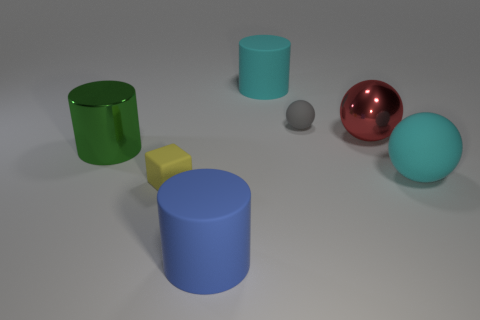Can you tell me what objects are in the image and their colors? Certainly! In the image, there are several three-dimensional objects with distinct colors. We have two cylinders, one painted green and the other blue. A sphere is present with a shiny metallic finish in red, alongside another matte sphere in cyan. Additionally, there's a smaller grey sphere and a yellow cube. 